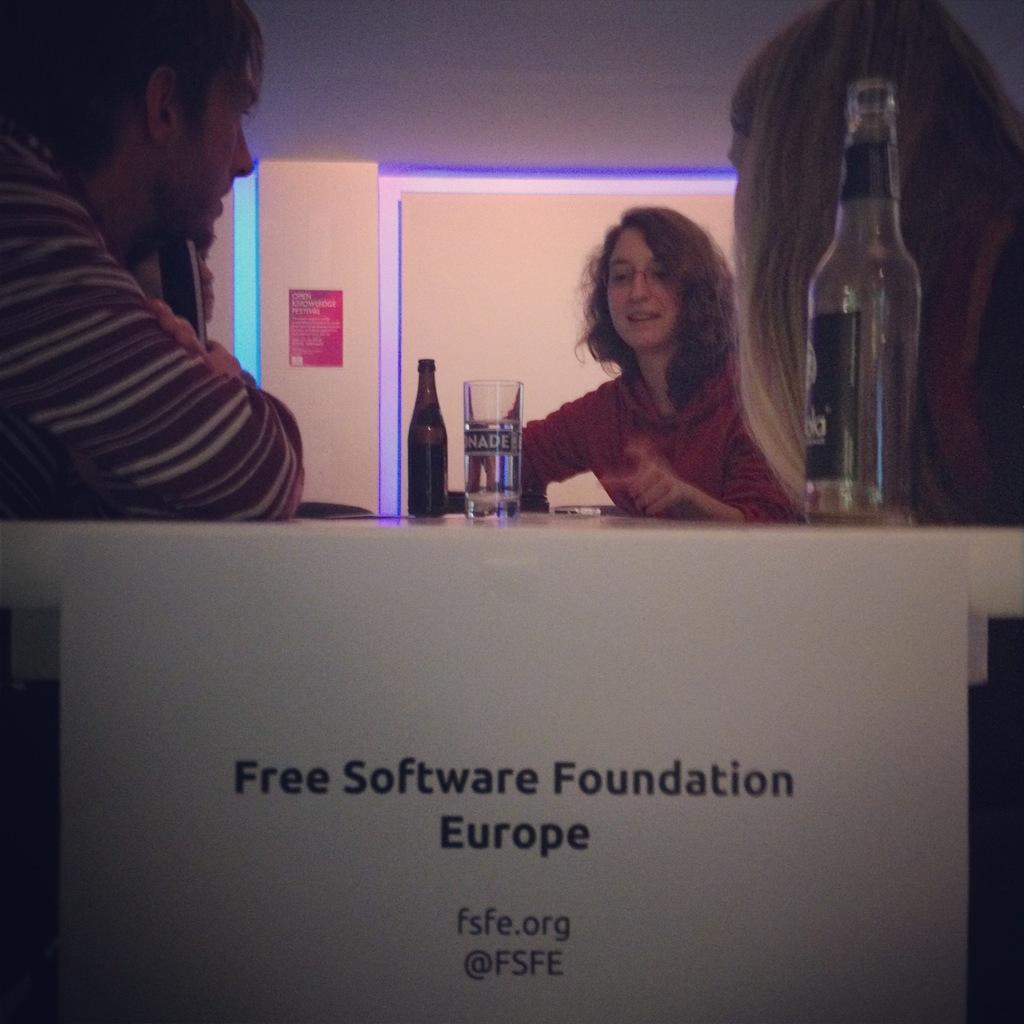In one or two sentences, can you explain what this image depicts? In this picture there are two women and men sitting on the chair. There is a glass, bottle, phone on the table. There is a poster on the wall. 